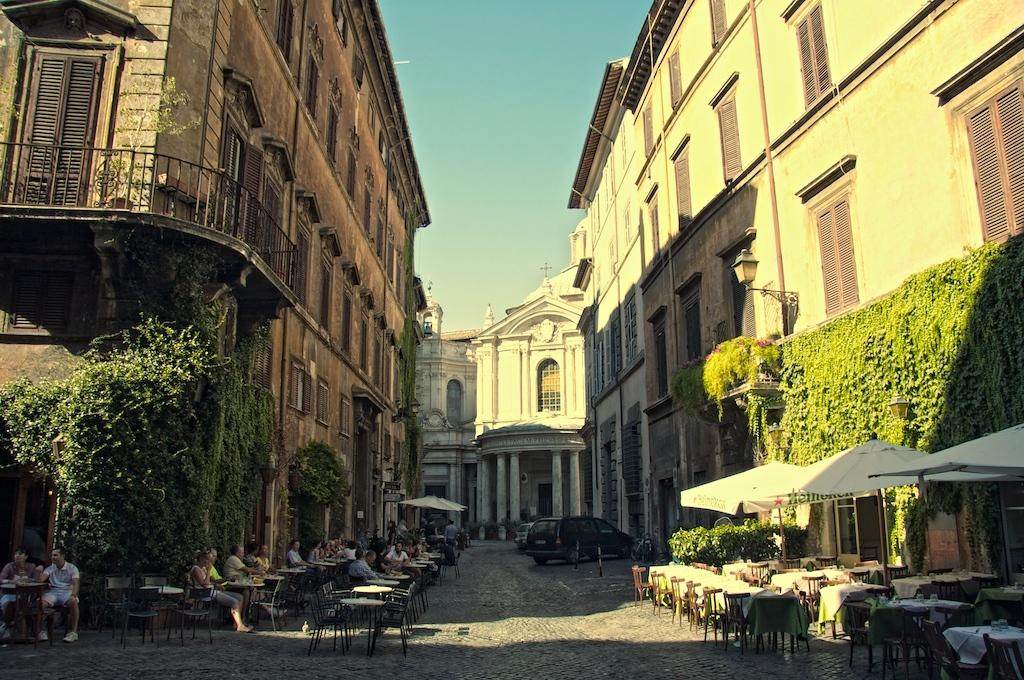What is the main feature in the middle of the image? There is a path in the middle of the image. What objects are placed on the path? Tables and chairs are present on the path. What type of vehicles can be seen on the path? Cars are visible on the path. What structures are located on either side of the path? There are buildings on either side of the path. What type of vegetation is in front of the buildings? Plants are in front of the buildings. What is visible above the scene? The sky is visible above the scene. What type of juice is being served at the tables in the image? There is no mention of juice or any beverages being served in the image. How many quarters are visible on the path in the image? There are no quarters visible on the path in the image. 